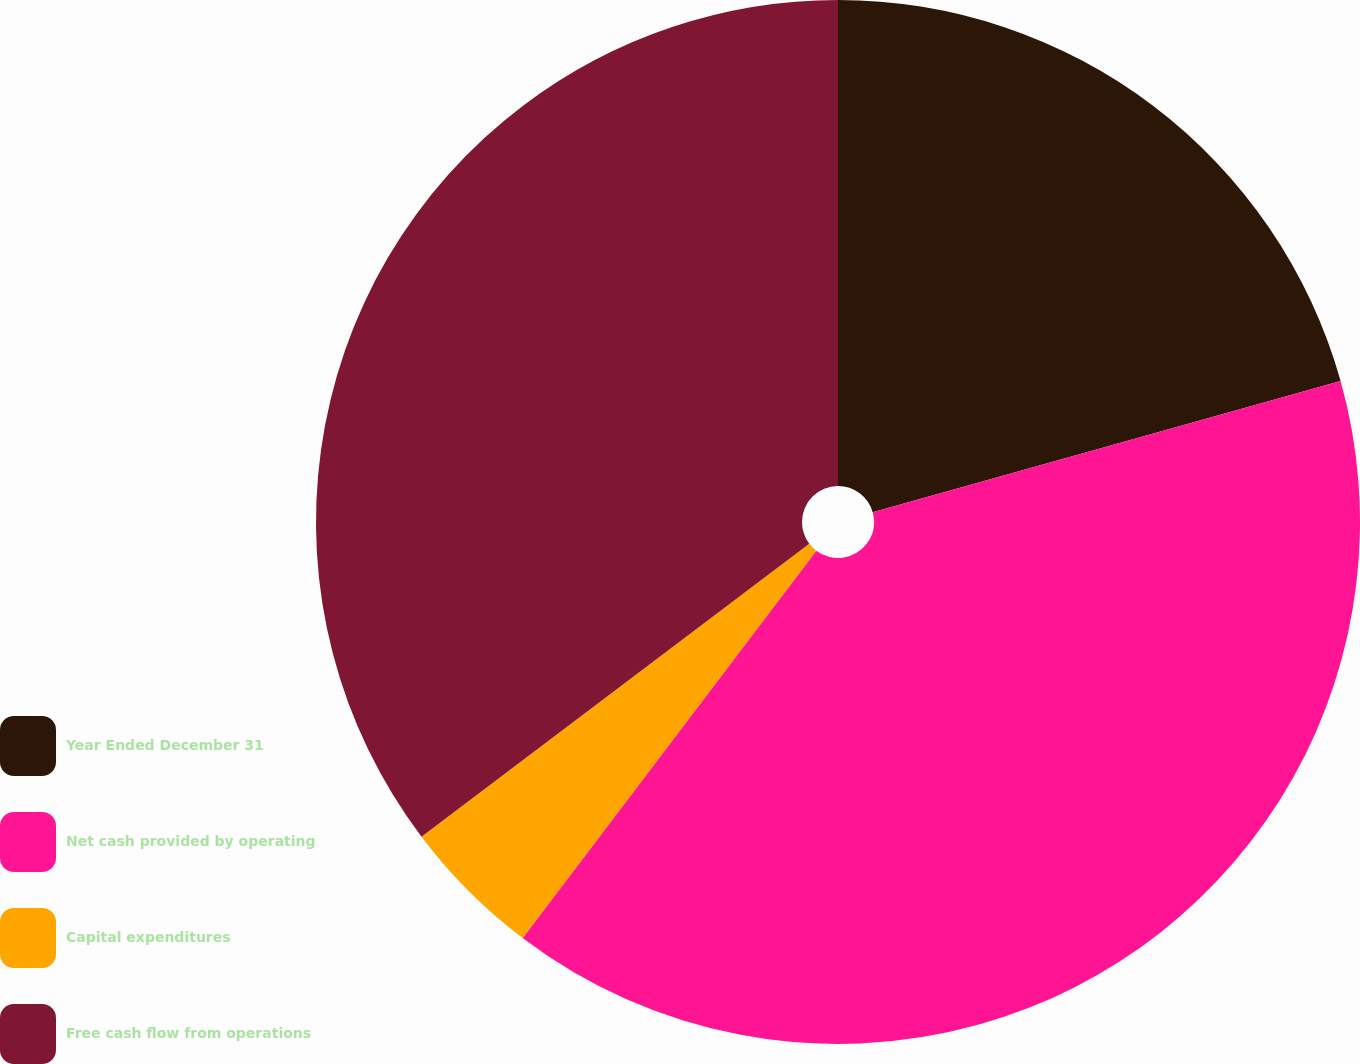Convert chart to OTSL. <chart><loc_0><loc_0><loc_500><loc_500><pie_chart><fcel>Year Ended December 31<fcel>Net cash provided by operating<fcel>Capital expenditures<fcel>Free cash flow from operations<nl><fcel>20.65%<fcel>39.68%<fcel>4.38%<fcel>35.3%<nl></chart> 